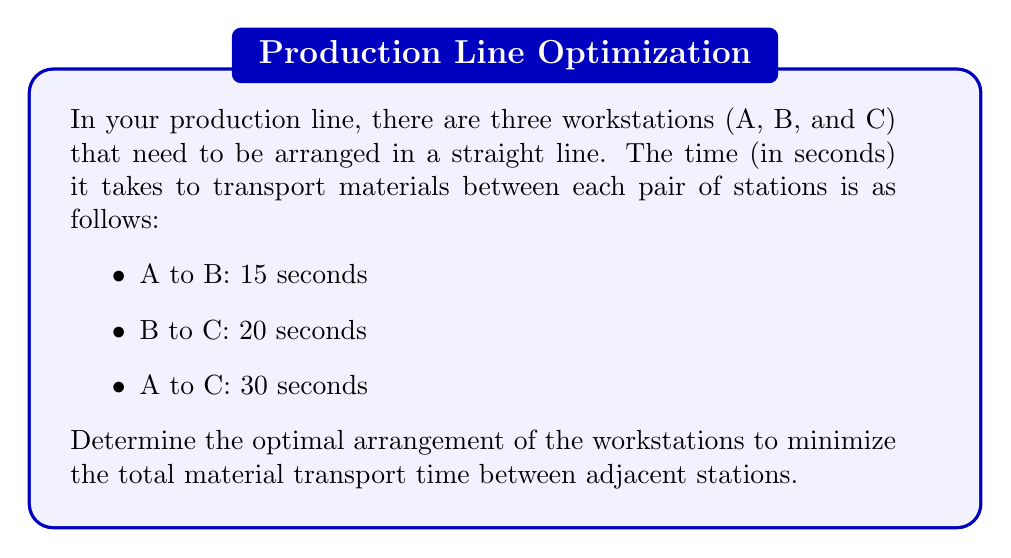Teach me how to tackle this problem. To solve this problem, we need to consider all possible arrangements of the three workstations and calculate the total transport time for each arrangement. Then, we'll choose the arrangement with the minimum total time.

There are 3! = 6 possible arrangements of the three workstations:

1. A - B - C
2. A - C - B
3. B - A - C
4. B - C - A
5. C - A - B
6. C - B - A

Let's calculate the total transport time for each arrangement:

1. A - B - C:
   Total time = Time(A to B) + Time(B to C) = 15 + 20 = 35 seconds

2. A - C - B:
   Total time = Time(A to C) + Time(C to B) = 30 + 20 = 50 seconds

3. B - A - C:
   Total time = Time(B to A) + Time(A to C) = 15 + 30 = 45 seconds

4. B - C - A:
   Total time = Time(B to C) + Time(C to A) = 20 + 30 = 50 seconds

5. C - A - B:
   Total time = Time(C to A) + Time(A to B) = 30 + 15 = 45 seconds

6. C - B - A:
   Total time = Time(C to B) + Time(B to A) = 20 + 15 = 35 seconds

Comparing the total times, we can see that arrangements 1 (A - B - C) and 6 (C - B - A) both result in the minimum total transport time of 35 seconds.

Therefore, the optimal arrangement of the workstations to minimize the total material transport time between adjacent stations is either A - B - C or C - B - A.
Answer: The optimal arrangement is either A - B - C or C - B - A, both resulting in a minimum total transport time of 35 seconds. 